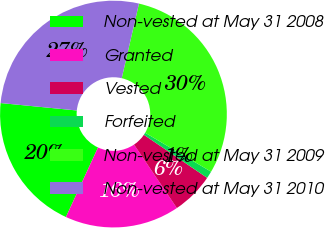Convert chart to OTSL. <chart><loc_0><loc_0><loc_500><loc_500><pie_chart><fcel>Non-vested at May 31 2008<fcel>Granted<fcel>Vested<fcel>Forfeited<fcel>Non-vested at May 31 2009<fcel>Non-vested at May 31 2010<nl><fcel>19.67%<fcel>16.33%<fcel>6.04%<fcel>1.03%<fcel>29.87%<fcel>27.07%<nl></chart> 